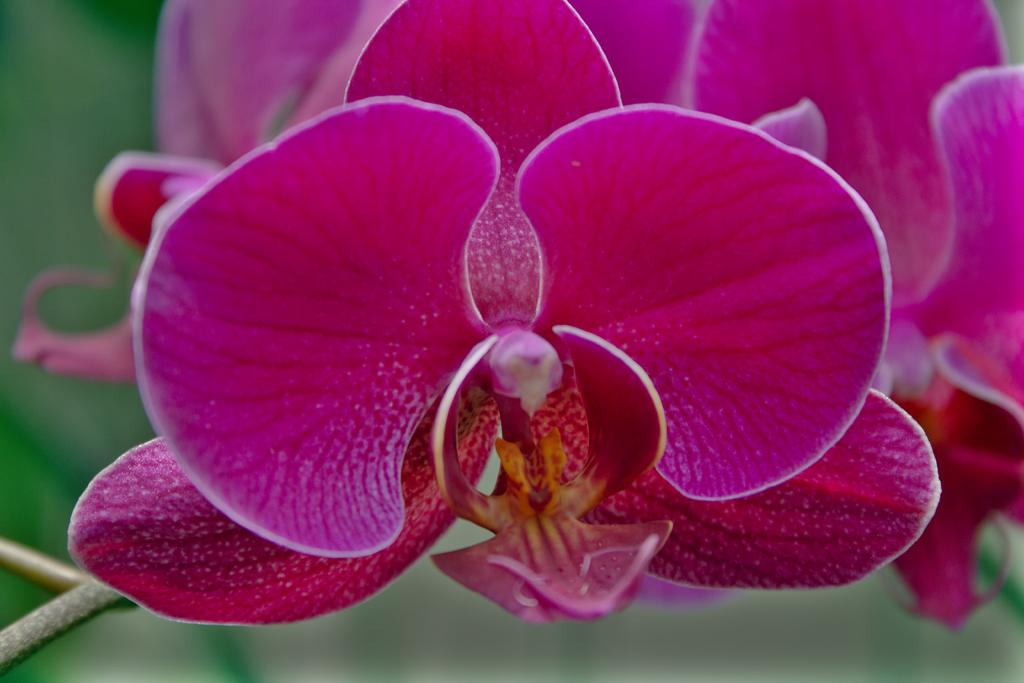What is the main subject of the image? The main subject of the image is flowers. Can you describe the flowers in the image? The flowers are purple in color. What else can be seen in the image besides the flowers? There are stems associated with the flowers. What type of competition is taking place in the image? There is no competition present in the image; it features flowers and their stems. Can you tell me how the river flows in the image? There is no river present in the image; it only contains flowers and their stems. 